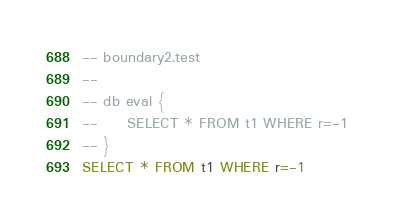Convert code to text. <code><loc_0><loc_0><loc_500><loc_500><_SQL_>-- boundary2.test
-- 
-- db eval {
--     SELECT * FROM t1 WHERE r=-1
-- }
SELECT * FROM t1 WHERE r=-1</code> 